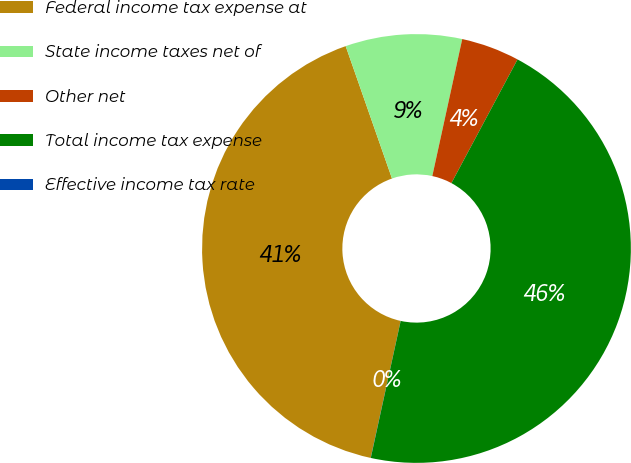<chart> <loc_0><loc_0><loc_500><loc_500><pie_chart><fcel>Federal income tax expense at<fcel>State income taxes net of<fcel>Other net<fcel>Total income tax expense<fcel>Effective income tax rate<nl><fcel>41.22%<fcel>8.78%<fcel>4.39%<fcel>45.61%<fcel>0.01%<nl></chart> 